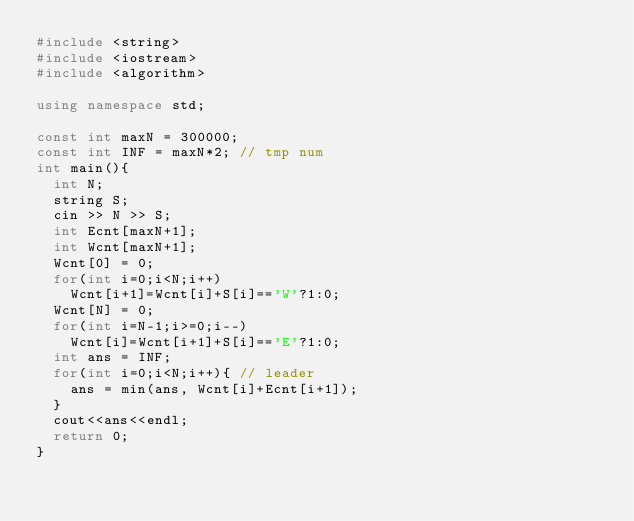Convert code to text. <code><loc_0><loc_0><loc_500><loc_500><_C++_>#include <string>
#include <iostream>
#include <algorithm>

using namespace std;

const int maxN = 300000;
const int INF = maxN*2; // tmp num
int main(){
  int N;
  string S;
  cin >> N >> S;
  int Ecnt[maxN+1];
  int Wcnt[maxN+1];
  Wcnt[0] = 0;
  for(int i=0;i<N;i++)
    Wcnt[i+1]=Wcnt[i]+S[i]=='W'?1:0;
  Wcnt[N] = 0;
  for(int i=N-1;i>=0;i--)
    Wcnt[i]=Wcnt[i+1]+S[i]=='E'?1:0;
  int ans = INF;
  for(int i=0;i<N;i++){ // leader
    ans = min(ans, Wcnt[i]+Ecnt[i+1]);
  }
  cout<<ans<<endl;
  return 0;
}</code> 